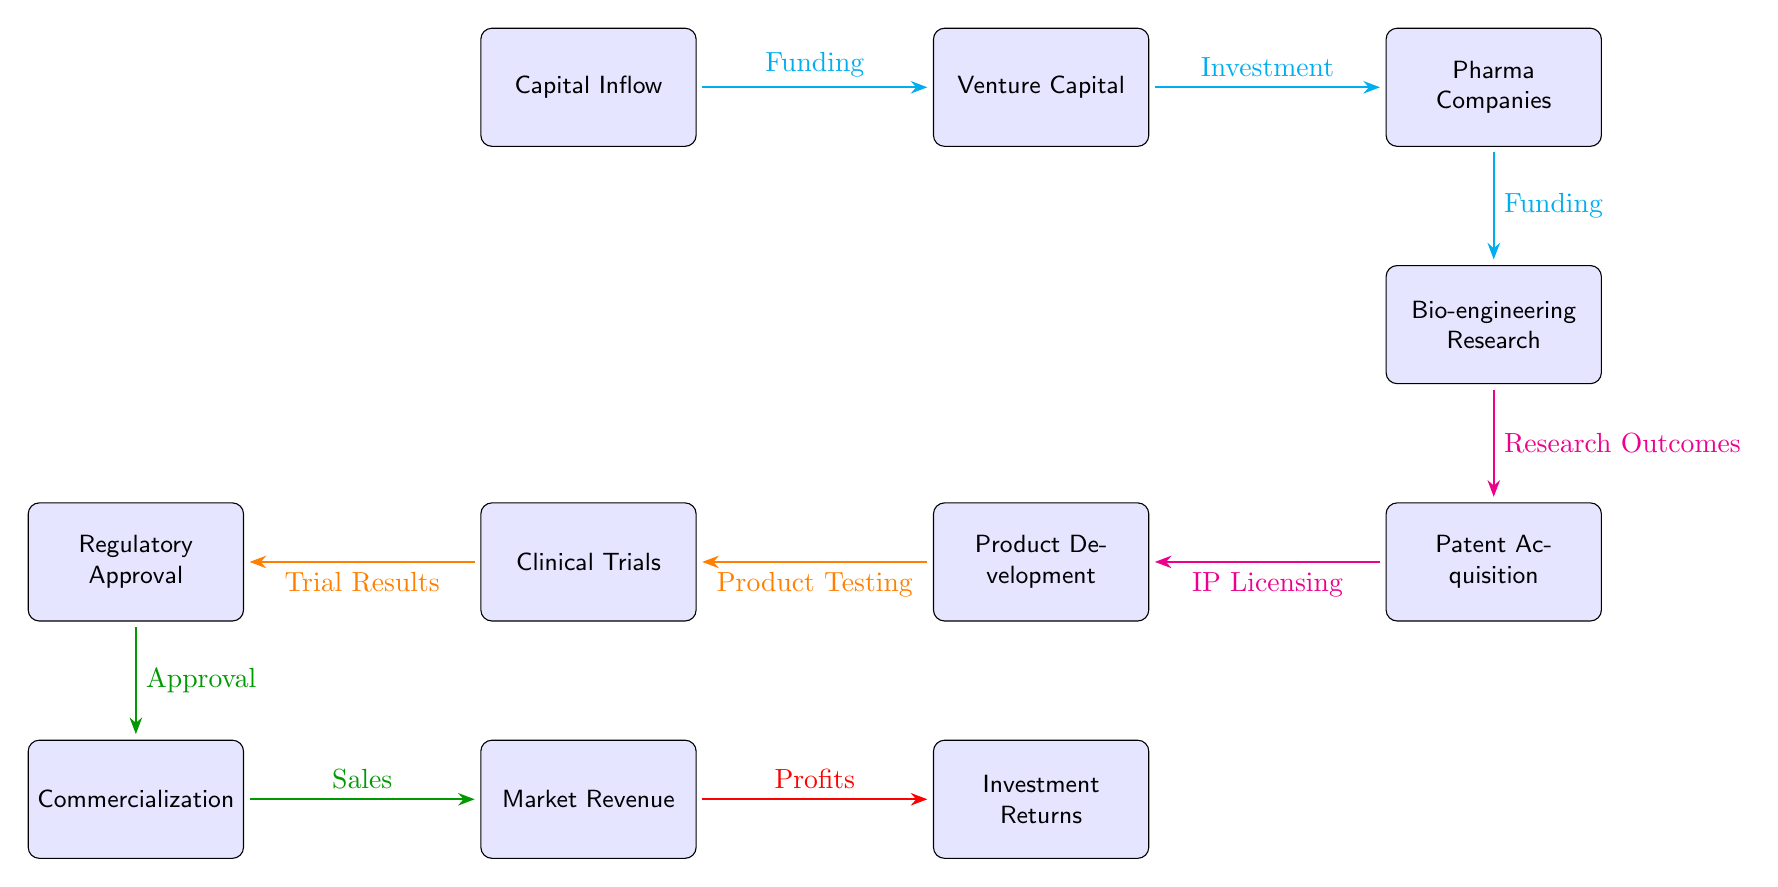What is the initial source of funding in the diagram? The diagram shows "Capital Inflow" as the starting point, represented on the far left. This node depicts where the financial resources begin before flowing towards venture capital and other entities.
Answer: Capital Inflow How many nodes are in the diagram? By counting each distinct box in the diagram, we can identify that there are ten nodes representing different stages in the process from funding to investment returns.
Answer: Ten What step follows "Patent Acquisition"? The flow from "Patent Acquisition" continues to "Product Development", indicating that after securing patents, the next phase involves developing products based on those patents.
Answer: Product Development Which two types of funding are depicted in the diagram? The diagram highlights "Funding" from both "Capital Inflow" to "Venture Capital" and from "Pharma Companies" to "Bio-engineering Research," demonstrating the funding flow at different stages.
Answer: Venture Capital and Pharma Companies What leads to "Market Revenue"? The path to "Market Revenue" starts after "Commercialization," as indicated by the flow from "Commercialization," thus revenue results from the sales of products after they have been commercialized.
Answer: Commercialization Explain the relationship between "Clinical Trials" and "Regulatory Approval." "Clinical Trials" precedes "Regulatory Approval," with the flow indicating that trial results must be evaluated and approved for regulatory compliance before moving forward. This shows a clear dependency in the research and development process.
Answer: Trial Results What is the end result of the financial flow represented in the diagram? The flow culminates in "Investment Returns," indicating that the financial investment in the development of bio-engineered food products ultimately leads to returns, showcasing the final outcome of the financial endeavor.
Answer: Investment Returns What node directly follows "Bio-engineering Research"? The node that directly follows "Bio-engineering Research" is "Patent Acquisition," implying that research outcomes lead to obtaining patents that protect the intellectual property developed.
Answer: Patent Acquisition What does "IP Licensing" contribute to in the diagram? "IP Licensing" is linked to "Product Development," denoting that acquiring intellectual property through licensing facilitates the development of actual bio-engineered food products further down the chain.
Answer: Product Development 